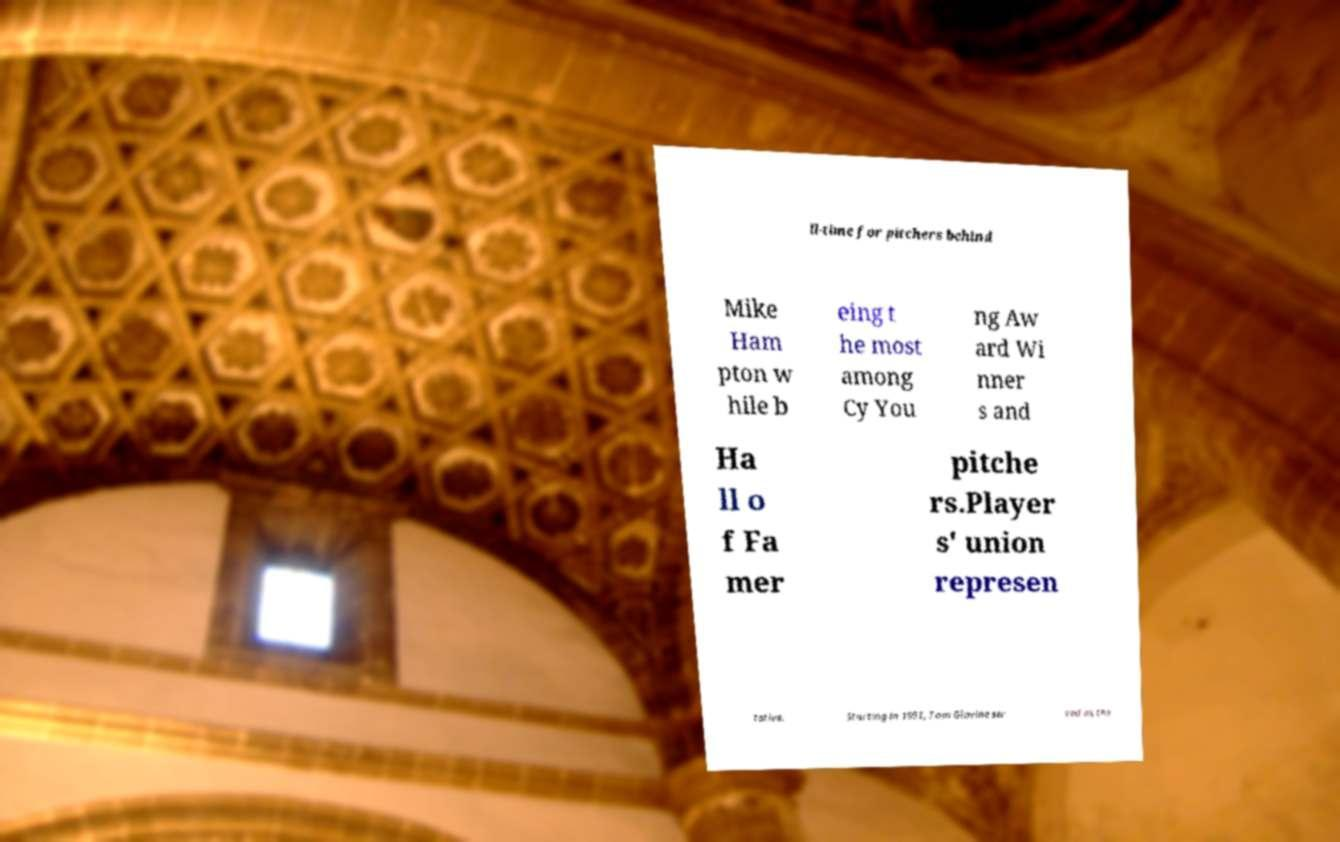Please identify and transcribe the text found in this image. ll-time for pitchers behind Mike Ham pton w hile b eing t he most among Cy You ng Aw ard Wi nner s and Ha ll o f Fa mer pitche rs.Player s' union represen tative. Starting in 1991, Tom Glavine ser ved as the 